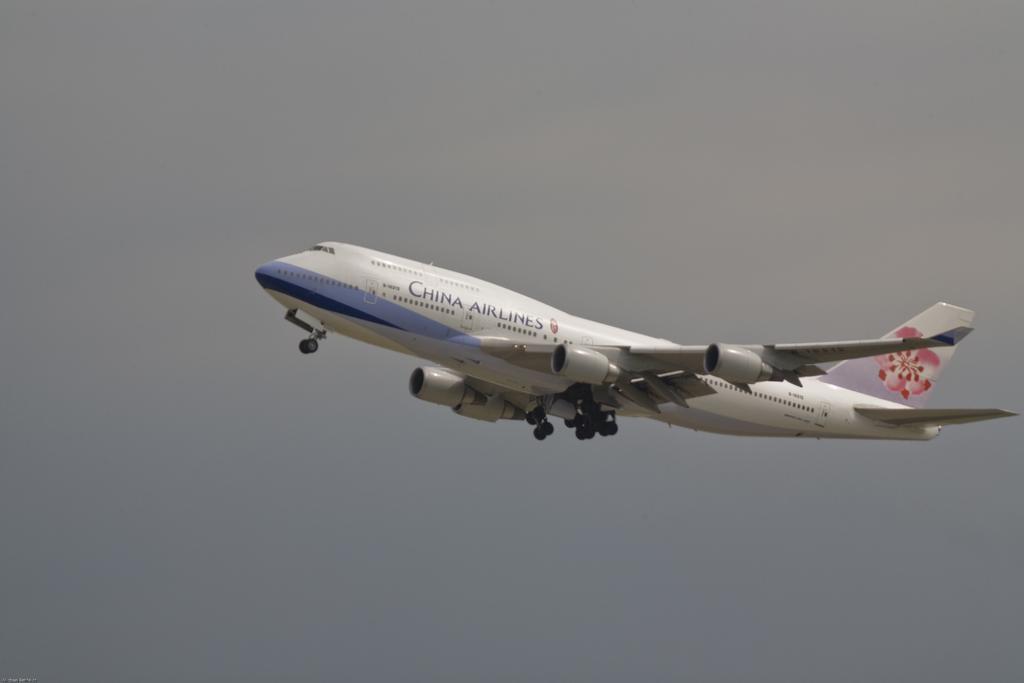Could you give a brief overview of what you see in this image? Here we can see an aeroplane flying in the air. In the background there is sky. 